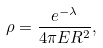<formula> <loc_0><loc_0><loc_500><loc_500>\rho = \frac { e ^ { - \lambda } } { 4 \pi E R ^ { 2 } } ,</formula> 